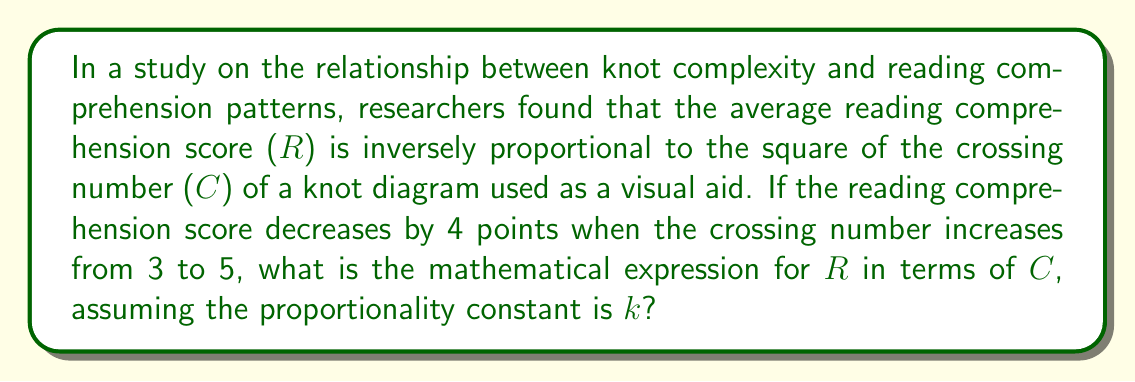Solve this math problem. 1. We are given that R is inversely proportional to C^2. This can be expressed as:
   $$ R = \frac{k}{C^2} $$
   where k is the proportionality constant.

2. We know that the score decreases by 4 points when C changes from 3 to 5. Let's express this:
   $$ \frac{k}{3^2} - \frac{k}{5^2} = 4 $$

3. Simplify the fractions:
   $$ \frac{k}{9} - \frac{k}{25} = 4 $$

4. Find a common denominator:
   $$ \frac{25k}{225} - \frac{9k}{225} = 4 $$

5. Simplify:
   $$ \frac{16k}{225} = 4 $$

6. Multiply both sides by 225:
   $$ 16k = 900 $$

7. Solve for k:
   $$ k = \frac{900}{16} = 56.25 $$

8. Substitute this value of k back into the original equation:
   $$ R = \frac{56.25}{C^2} $$
Answer: $$ R = \frac{56.25}{C^2} $$ 